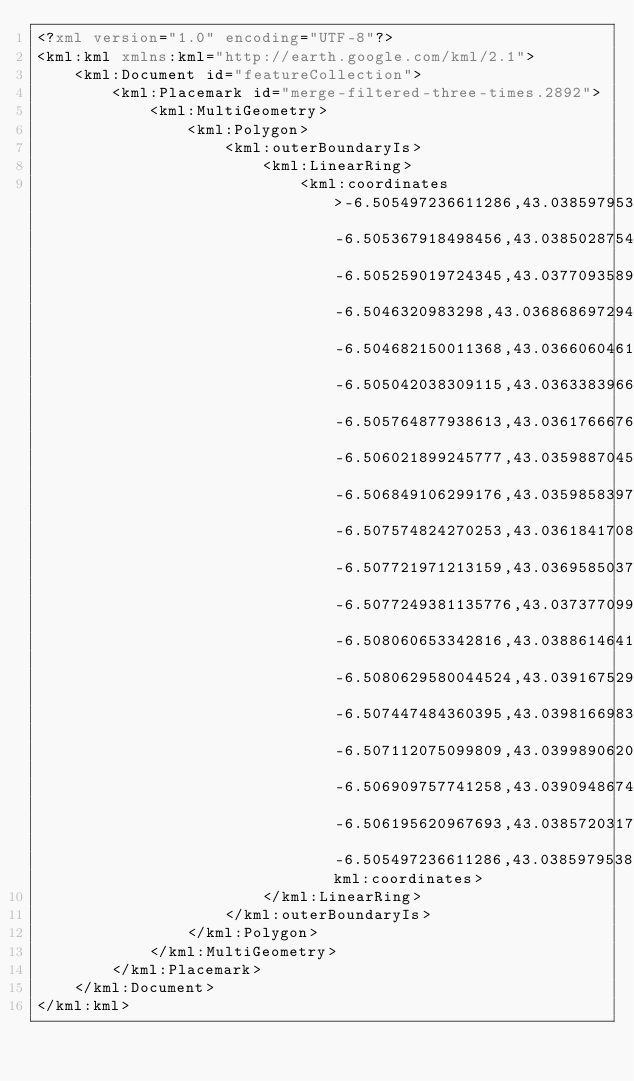Convert code to text. <code><loc_0><loc_0><loc_500><loc_500><_XML_><?xml version="1.0" encoding="UTF-8"?>
<kml:kml xmlns:kml="http://earth.google.com/kml/2.1">
    <kml:Document id="featureCollection">
        <kml:Placemark id="merge-filtered-three-times.2892">
            <kml:MultiGeometry>
                <kml:Polygon>
                    <kml:outerBoundaryIs>
                        <kml:LinearRing>
                            <kml:coordinates>-6.505497236611286,43.03859795386198 -6.505367918498456,43.03850287545185 -6.505259019724345,43.03770935894656 -6.5046320983298,43.036868697294175 -6.504682150011368,43.03660604619022 -6.505042038309115,43.036338396645874 -6.505764877938613,43.03617666769649 -6.506021899245777,43.035988704598736 -6.506849106299176,43.03598583976074 -6.507574824270253,43.03618417089214 -6.507721971213159,43.03695850374822 -6.5077249381135776,43.03737709936992 -6.508060653342816,43.03886146414087 -6.5080629580044524,43.039167529964075 -6.507447484360395,43.039816698304215 -6.507112075099809,43.03998906201745 -6.506909757741258,43.03909486740793 -6.506195620967693,43.03857203178495 -6.505497236611286,43.03859795386198</kml:coordinates>
                        </kml:LinearRing>
                    </kml:outerBoundaryIs>
                </kml:Polygon>
            </kml:MultiGeometry>
        </kml:Placemark>
    </kml:Document>
</kml:kml>
</code> 